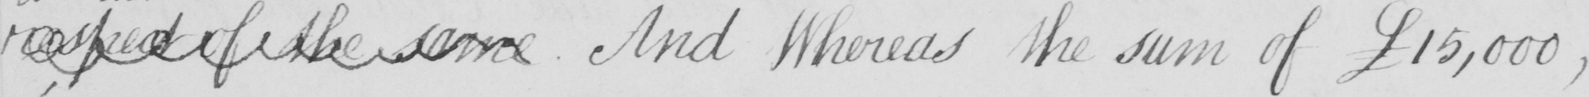What does this handwritten line say? respect of the same  . And Whereas the sum of  £15,000  , 